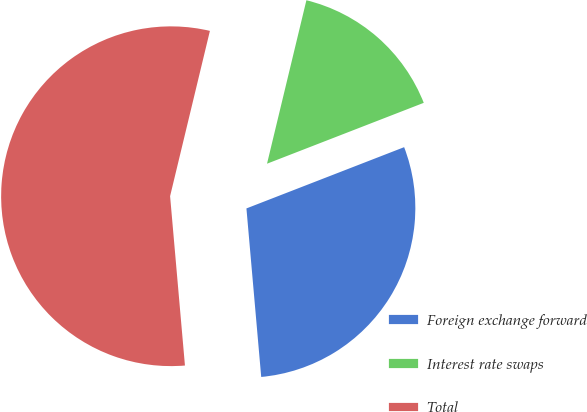Convert chart to OTSL. <chart><loc_0><loc_0><loc_500><loc_500><pie_chart><fcel>Foreign exchange forward<fcel>Interest rate swaps<fcel>Total<nl><fcel>29.5%<fcel>15.34%<fcel>55.15%<nl></chart> 